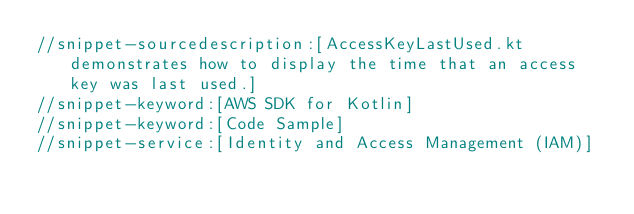<code> <loc_0><loc_0><loc_500><loc_500><_Kotlin_>//snippet-sourcedescription:[AccessKeyLastUsed.kt demonstrates how to display the time that an access key was last used.]
//snippet-keyword:[AWS SDK for Kotlin]
//snippet-keyword:[Code Sample]
//snippet-service:[Identity and Access Management (IAM)]</code> 